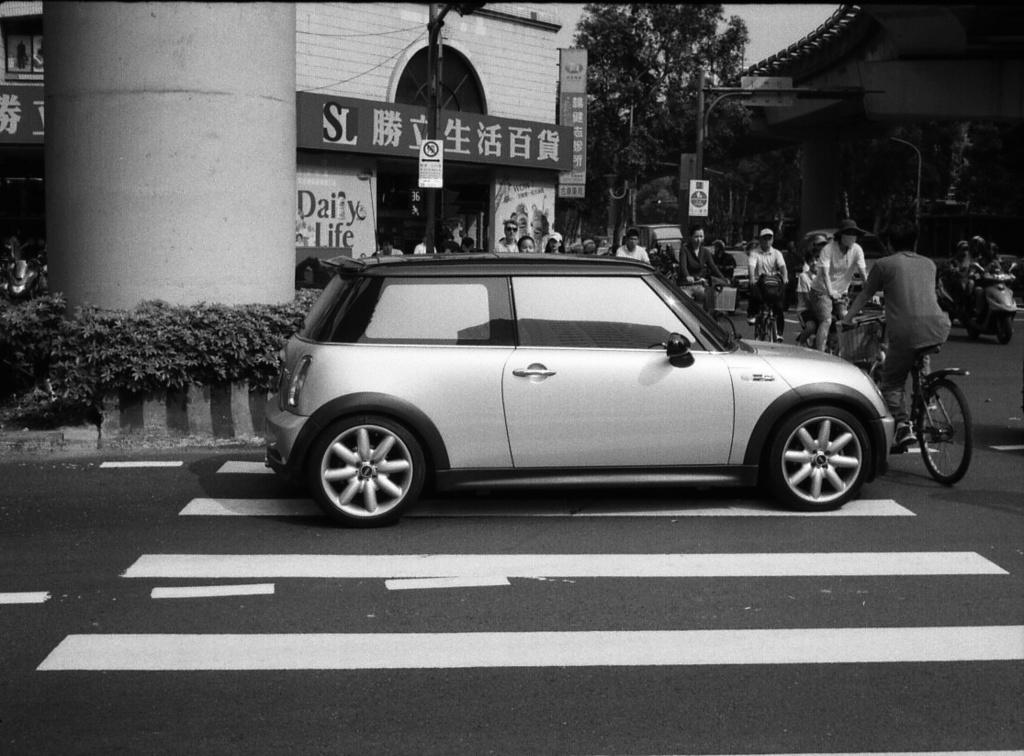What type of transportation infrastructure is visible in the image? There is a street, a road, a car, and people riding bicycles in the image. What type of structure can be seen in the image? There is a pillar and a flyover in the image. What type of commercial establishments are present in the image? There are shops in the image. Can you see any signs of regret in the image? There is no indication of regret in the image; it features a street, a road, a car, a pillar, a flyover, shops, and people riding bicycles. Is there any writing visible on the car in the image? There is no writing visible on the car in the image. 